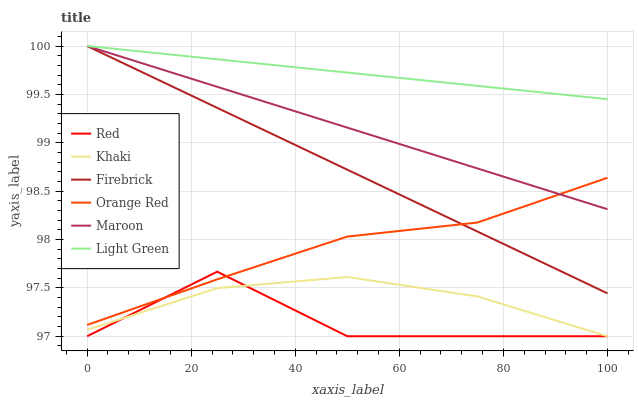Does Red have the minimum area under the curve?
Answer yes or no. Yes. Does Light Green have the maximum area under the curve?
Answer yes or no. Yes. Does Firebrick have the minimum area under the curve?
Answer yes or no. No. Does Firebrick have the maximum area under the curve?
Answer yes or no. No. Is Maroon the smoothest?
Answer yes or no. Yes. Is Red the roughest?
Answer yes or no. Yes. Is Firebrick the smoothest?
Answer yes or no. No. Is Firebrick the roughest?
Answer yes or no. No. Does Firebrick have the lowest value?
Answer yes or no. No. Does Orange Red have the highest value?
Answer yes or no. No. Is Red less than Light Green?
Answer yes or no. Yes. Is Maroon greater than Khaki?
Answer yes or no. Yes. Does Red intersect Light Green?
Answer yes or no. No. 